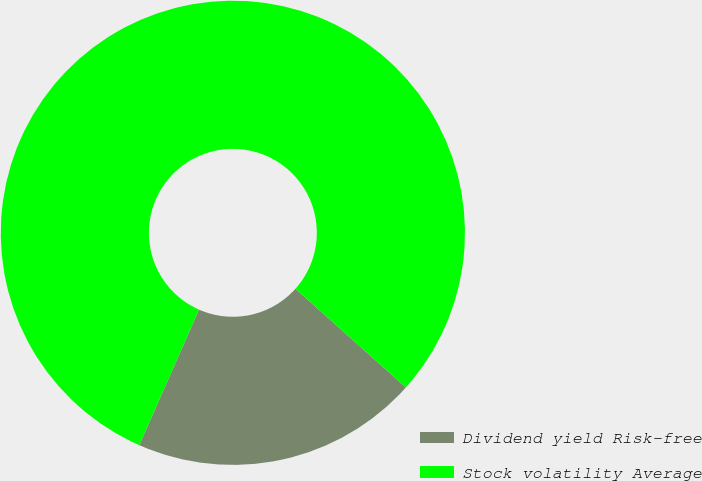Convert chart. <chart><loc_0><loc_0><loc_500><loc_500><pie_chart><fcel>Dividend yield Risk-free<fcel>Stock volatility Average<nl><fcel>20.0%<fcel>80.0%<nl></chart> 